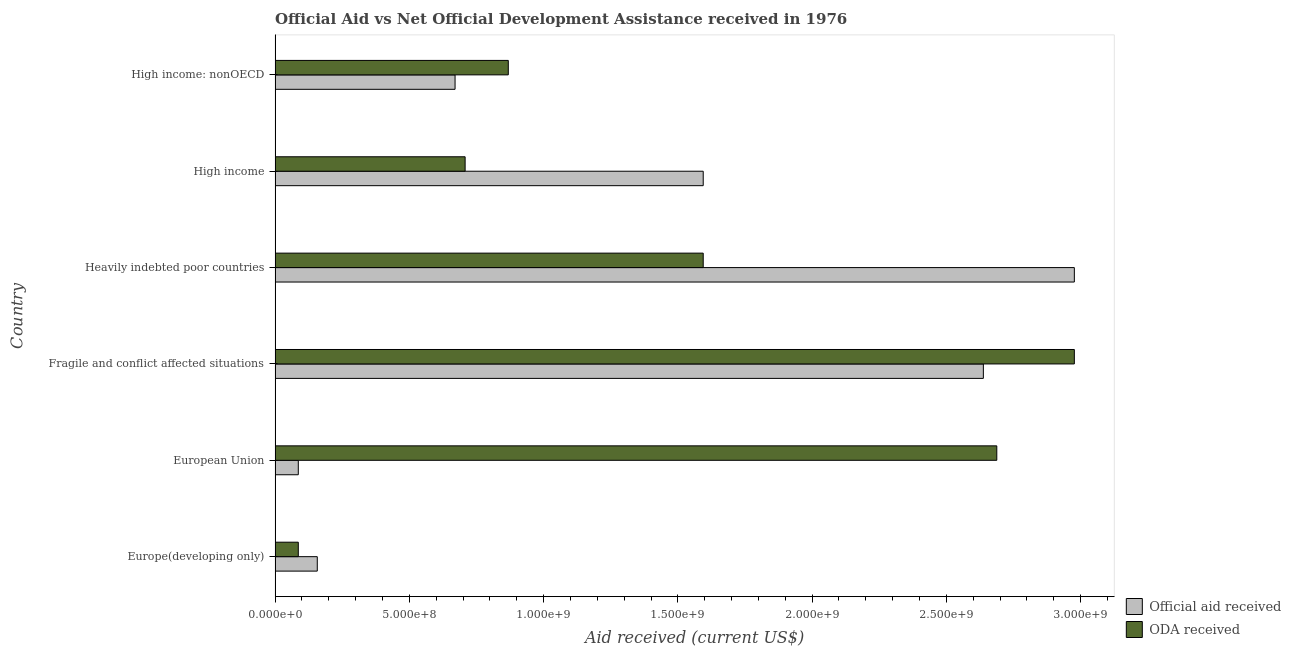How many different coloured bars are there?
Give a very brief answer. 2. Are the number of bars per tick equal to the number of legend labels?
Your answer should be compact. Yes. Are the number of bars on each tick of the Y-axis equal?
Give a very brief answer. Yes. How many bars are there on the 3rd tick from the bottom?
Provide a short and direct response. 2. What is the label of the 3rd group of bars from the top?
Your response must be concise. Heavily indebted poor countries. What is the official aid received in Europe(developing only)?
Offer a terse response. 1.57e+08. Across all countries, what is the maximum official aid received?
Provide a short and direct response. 2.98e+09. Across all countries, what is the minimum oda received?
Your answer should be compact. 8.65e+07. In which country was the official aid received maximum?
Provide a short and direct response. Heavily indebted poor countries. In which country was the oda received minimum?
Offer a terse response. Europe(developing only). What is the total oda received in the graph?
Your answer should be compact. 8.92e+09. What is the difference between the official aid received in Heavily indebted poor countries and that in High income: nonOECD?
Ensure brevity in your answer.  2.31e+09. What is the difference between the official aid received in High income and the oda received in High income: nonOECD?
Make the answer very short. 7.26e+08. What is the average oda received per country?
Your answer should be compact. 1.49e+09. What is the difference between the official aid received and oda received in Europe(developing only)?
Offer a very short reply. 7.07e+07. In how many countries, is the oda received greater than 2300000000 US$?
Give a very brief answer. 2. What is the ratio of the oda received in Europe(developing only) to that in Heavily indebted poor countries?
Ensure brevity in your answer.  0.05. Is the oda received in Europe(developing only) less than that in High income?
Provide a short and direct response. Yes. Is the difference between the oda received in Europe(developing only) and High income: nonOECD greater than the difference between the official aid received in Europe(developing only) and High income: nonOECD?
Ensure brevity in your answer.  No. What is the difference between the highest and the second highest official aid received?
Offer a very short reply. 3.39e+08. What is the difference between the highest and the lowest official aid received?
Provide a short and direct response. 2.89e+09. In how many countries, is the oda received greater than the average oda received taken over all countries?
Offer a very short reply. 3. Is the sum of the oda received in Fragile and conflict affected situations and Heavily indebted poor countries greater than the maximum official aid received across all countries?
Offer a very short reply. Yes. What does the 1st bar from the top in High income: nonOECD represents?
Offer a very short reply. ODA received. What does the 1st bar from the bottom in High income: nonOECD represents?
Provide a succinct answer. Official aid received. How many bars are there?
Make the answer very short. 12. How many countries are there in the graph?
Keep it short and to the point. 6. What is the difference between two consecutive major ticks on the X-axis?
Provide a succinct answer. 5.00e+08. Are the values on the major ticks of X-axis written in scientific E-notation?
Ensure brevity in your answer.  Yes. How are the legend labels stacked?
Offer a very short reply. Vertical. What is the title of the graph?
Your answer should be compact. Official Aid vs Net Official Development Assistance received in 1976 . What is the label or title of the X-axis?
Offer a very short reply. Aid received (current US$). What is the label or title of the Y-axis?
Ensure brevity in your answer.  Country. What is the Aid received (current US$) of Official aid received in Europe(developing only)?
Keep it short and to the point. 1.57e+08. What is the Aid received (current US$) in ODA received in Europe(developing only)?
Your answer should be very brief. 8.65e+07. What is the Aid received (current US$) of Official aid received in European Union?
Ensure brevity in your answer.  8.65e+07. What is the Aid received (current US$) in ODA received in European Union?
Your answer should be compact. 2.69e+09. What is the Aid received (current US$) of Official aid received in Fragile and conflict affected situations?
Keep it short and to the point. 2.64e+09. What is the Aid received (current US$) in ODA received in Fragile and conflict affected situations?
Your answer should be very brief. 2.98e+09. What is the Aid received (current US$) in Official aid received in Heavily indebted poor countries?
Give a very brief answer. 2.98e+09. What is the Aid received (current US$) in ODA received in Heavily indebted poor countries?
Offer a very short reply. 1.59e+09. What is the Aid received (current US$) of Official aid received in High income?
Your response must be concise. 1.59e+09. What is the Aid received (current US$) of ODA received in High income?
Your answer should be very brief. 7.08e+08. What is the Aid received (current US$) in Official aid received in High income: nonOECD?
Make the answer very short. 6.70e+08. What is the Aid received (current US$) of ODA received in High income: nonOECD?
Provide a short and direct response. 8.69e+08. Across all countries, what is the maximum Aid received (current US$) in Official aid received?
Your answer should be very brief. 2.98e+09. Across all countries, what is the maximum Aid received (current US$) of ODA received?
Your answer should be compact. 2.98e+09. Across all countries, what is the minimum Aid received (current US$) in Official aid received?
Keep it short and to the point. 8.65e+07. Across all countries, what is the minimum Aid received (current US$) of ODA received?
Give a very brief answer. 8.65e+07. What is the total Aid received (current US$) of Official aid received in the graph?
Offer a very short reply. 8.12e+09. What is the total Aid received (current US$) of ODA received in the graph?
Your answer should be very brief. 8.92e+09. What is the difference between the Aid received (current US$) of Official aid received in Europe(developing only) and that in European Union?
Make the answer very short. 7.07e+07. What is the difference between the Aid received (current US$) in ODA received in Europe(developing only) and that in European Union?
Offer a very short reply. -2.60e+09. What is the difference between the Aid received (current US$) of Official aid received in Europe(developing only) and that in Fragile and conflict affected situations?
Keep it short and to the point. -2.48e+09. What is the difference between the Aid received (current US$) in ODA received in Europe(developing only) and that in Fragile and conflict affected situations?
Your answer should be very brief. -2.89e+09. What is the difference between the Aid received (current US$) of Official aid received in Europe(developing only) and that in Heavily indebted poor countries?
Provide a short and direct response. -2.82e+09. What is the difference between the Aid received (current US$) in ODA received in Europe(developing only) and that in Heavily indebted poor countries?
Give a very brief answer. -1.51e+09. What is the difference between the Aid received (current US$) in Official aid received in Europe(developing only) and that in High income?
Offer a very short reply. -1.44e+09. What is the difference between the Aid received (current US$) of ODA received in Europe(developing only) and that in High income?
Give a very brief answer. -6.21e+08. What is the difference between the Aid received (current US$) in Official aid received in Europe(developing only) and that in High income: nonOECD?
Keep it short and to the point. -5.13e+08. What is the difference between the Aid received (current US$) in ODA received in Europe(developing only) and that in High income: nonOECD?
Ensure brevity in your answer.  -7.82e+08. What is the difference between the Aid received (current US$) of Official aid received in European Union and that in Fragile and conflict affected situations?
Offer a very short reply. -2.55e+09. What is the difference between the Aid received (current US$) in ODA received in European Union and that in Fragile and conflict affected situations?
Your response must be concise. -2.89e+08. What is the difference between the Aid received (current US$) in Official aid received in European Union and that in Heavily indebted poor countries?
Keep it short and to the point. -2.89e+09. What is the difference between the Aid received (current US$) in ODA received in European Union and that in Heavily indebted poor countries?
Provide a short and direct response. 1.09e+09. What is the difference between the Aid received (current US$) of Official aid received in European Union and that in High income?
Provide a short and direct response. -1.51e+09. What is the difference between the Aid received (current US$) of ODA received in European Union and that in High income?
Your answer should be very brief. 1.98e+09. What is the difference between the Aid received (current US$) of Official aid received in European Union and that in High income: nonOECD?
Your answer should be compact. -5.84e+08. What is the difference between the Aid received (current US$) in ODA received in European Union and that in High income: nonOECD?
Your answer should be compact. 1.82e+09. What is the difference between the Aid received (current US$) in Official aid received in Fragile and conflict affected situations and that in Heavily indebted poor countries?
Ensure brevity in your answer.  -3.39e+08. What is the difference between the Aid received (current US$) in ODA received in Fragile and conflict affected situations and that in Heavily indebted poor countries?
Your response must be concise. 1.38e+09. What is the difference between the Aid received (current US$) of Official aid received in Fragile and conflict affected situations and that in High income?
Give a very brief answer. 1.04e+09. What is the difference between the Aid received (current US$) of ODA received in Fragile and conflict affected situations and that in High income?
Your answer should be compact. 2.27e+09. What is the difference between the Aid received (current US$) of Official aid received in Fragile and conflict affected situations and that in High income: nonOECD?
Give a very brief answer. 1.97e+09. What is the difference between the Aid received (current US$) of ODA received in Fragile and conflict affected situations and that in High income: nonOECD?
Provide a succinct answer. 2.11e+09. What is the difference between the Aid received (current US$) in Official aid received in Heavily indebted poor countries and that in High income?
Offer a terse response. 1.38e+09. What is the difference between the Aid received (current US$) in ODA received in Heavily indebted poor countries and that in High income?
Offer a terse response. 8.87e+08. What is the difference between the Aid received (current US$) in Official aid received in Heavily indebted poor countries and that in High income: nonOECD?
Ensure brevity in your answer.  2.31e+09. What is the difference between the Aid received (current US$) in ODA received in Heavily indebted poor countries and that in High income: nonOECD?
Provide a short and direct response. 7.26e+08. What is the difference between the Aid received (current US$) of Official aid received in High income and that in High income: nonOECD?
Provide a short and direct response. 9.24e+08. What is the difference between the Aid received (current US$) in ODA received in High income and that in High income: nonOECD?
Offer a terse response. -1.61e+08. What is the difference between the Aid received (current US$) in Official aid received in Europe(developing only) and the Aid received (current US$) in ODA received in European Union?
Offer a very short reply. -2.53e+09. What is the difference between the Aid received (current US$) in Official aid received in Europe(developing only) and the Aid received (current US$) in ODA received in Fragile and conflict affected situations?
Keep it short and to the point. -2.82e+09. What is the difference between the Aid received (current US$) of Official aid received in Europe(developing only) and the Aid received (current US$) of ODA received in Heavily indebted poor countries?
Your answer should be very brief. -1.44e+09. What is the difference between the Aid received (current US$) of Official aid received in Europe(developing only) and the Aid received (current US$) of ODA received in High income?
Make the answer very short. -5.51e+08. What is the difference between the Aid received (current US$) in Official aid received in Europe(developing only) and the Aid received (current US$) in ODA received in High income: nonOECD?
Offer a very short reply. -7.11e+08. What is the difference between the Aid received (current US$) of Official aid received in European Union and the Aid received (current US$) of ODA received in Fragile and conflict affected situations?
Make the answer very short. -2.89e+09. What is the difference between the Aid received (current US$) of Official aid received in European Union and the Aid received (current US$) of ODA received in Heavily indebted poor countries?
Ensure brevity in your answer.  -1.51e+09. What is the difference between the Aid received (current US$) in Official aid received in European Union and the Aid received (current US$) in ODA received in High income?
Your answer should be compact. -6.21e+08. What is the difference between the Aid received (current US$) in Official aid received in European Union and the Aid received (current US$) in ODA received in High income: nonOECD?
Provide a succinct answer. -7.82e+08. What is the difference between the Aid received (current US$) of Official aid received in Fragile and conflict affected situations and the Aid received (current US$) of ODA received in Heavily indebted poor countries?
Give a very brief answer. 1.04e+09. What is the difference between the Aid received (current US$) in Official aid received in Fragile and conflict affected situations and the Aid received (current US$) in ODA received in High income?
Provide a succinct answer. 1.93e+09. What is the difference between the Aid received (current US$) of Official aid received in Fragile and conflict affected situations and the Aid received (current US$) of ODA received in High income: nonOECD?
Your answer should be very brief. 1.77e+09. What is the difference between the Aid received (current US$) of Official aid received in Heavily indebted poor countries and the Aid received (current US$) of ODA received in High income?
Your answer should be compact. 2.27e+09. What is the difference between the Aid received (current US$) in Official aid received in Heavily indebted poor countries and the Aid received (current US$) in ODA received in High income: nonOECD?
Give a very brief answer. 2.11e+09. What is the difference between the Aid received (current US$) in Official aid received in High income and the Aid received (current US$) in ODA received in High income: nonOECD?
Offer a terse response. 7.26e+08. What is the average Aid received (current US$) in Official aid received per country?
Offer a very short reply. 1.35e+09. What is the average Aid received (current US$) in ODA received per country?
Provide a short and direct response. 1.49e+09. What is the difference between the Aid received (current US$) of Official aid received and Aid received (current US$) of ODA received in Europe(developing only)?
Ensure brevity in your answer.  7.07e+07. What is the difference between the Aid received (current US$) of Official aid received and Aid received (current US$) of ODA received in European Union?
Your response must be concise. -2.60e+09. What is the difference between the Aid received (current US$) of Official aid received and Aid received (current US$) of ODA received in Fragile and conflict affected situations?
Offer a terse response. -3.39e+08. What is the difference between the Aid received (current US$) in Official aid received and Aid received (current US$) in ODA received in Heavily indebted poor countries?
Your answer should be very brief. 1.38e+09. What is the difference between the Aid received (current US$) of Official aid received and Aid received (current US$) of ODA received in High income?
Keep it short and to the point. 8.87e+08. What is the difference between the Aid received (current US$) of Official aid received and Aid received (current US$) of ODA received in High income: nonOECD?
Ensure brevity in your answer.  -1.98e+08. What is the ratio of the Aid received (current US$) of Official aid received in Europe(developing only) to that in European Union?
Provide a short and direct response. 1.82. What is the ratio of the Aid received (current US$) of ODA received in Europe(developing only) to that in European Union?
Your answer should be very brief. 0.03. What is the ratio of the Aid received (current US$) of Official aid received in Europe(developing only) to that in Fragile and conflict affected situations?
Ensure brevity in your answer.  0.06. What is the ratio of the Aid received (current US$) in ODA received in Europe(developing only) to that in Fragile and conflict affected situations?
Provide a succinct answer. 0.03. What is the ratio of the Aid received (current US$) in Official aid received in Europe(developing only) to that in Heavily indebted poor countries?
Provide a succinct answer. 0.05. What is the ratio of the Aid received (current US$) in ODA received in Europe(developing only) to that in Heavily indebted poor countries?
Offer a terse response. 0.05. What is the ratio of the Aid received (current US$) of Official aid received in Europe(developing only) to that in High income?
Provide a succinct answer. 0.1. What is the ratio of the Aid received (current US$) in ODA received in Europe(developing only) to that in High income?
Keep it short and to the point. 0.12. What is the ratio of the Aid received (current US$) in Official aid received in Europe(developing only) to that in High income: nonOECD?
Provide a short and direct response. 0.23. What is the ratio of the Aid received (current US$) in ODA received in Europe(developing only) to that in High income: nonOECD?
Offer a very short reply. 0.1. What is the ratio of the Aid received (current US$) in Official aid received in European Union to that in Fragile and conflict affected situations?
Your answer should be compact. 0.03. What is the ratio of the Aid received (current US$) of ODA received in European Union to that in Fragile and conflict affected situations?
Make the answer very short. 0.9. What is the ratio of the Aid received (current US$) in Official aid received in European Union to that in Heavily indebted poor countries?
Offer a very short reply. 0.03. What is the ratio of the Aid received (current US$) in ODA received in European Union to that in Heavily indebted poor countries?
Ensure brevity in your answer.  1.69. What is the ratio of the Aid received (current US$) of Official aid received in European Union to that in High income?
Offer a terse response. 0.05. What is the ratio of the Aid received (current US$) of ODA received in European Union to that in High income?
Make the answer very short. 3.8. What is the ratio of the Aid received (current US$) of Official aid received in European Union to that in High income: nonOECD?
Your answer should be compact. 0.13. What is the ratio of the Aid received (current US$) in ODA received in European Union to that in High income: nonOECD?
Your answer should be compact. 3.09. What is the ratio of the Aid received (current US$) in Official aid received in Fragile and conflict affected situations to that in Heavily indebted poor countries?
Your answer should be compact. 0.89. What is the ratio of the Aid received (current US$) in ODA received in Fragile and conflict affected situations to that in Heavily indebted poor countries?
Ensure brevity in your answer.  1.87. What is the ratio of the Aid received (current US$) in Official aid received in Fragile and conflict affected situations to that in High income?
Your response must be concise. 1.65. What is the ratio of the Aid received (current US$) in ODA received in Fragile and conflict affected situations to that in High income?
Make the answer very short. 4.21. What is the ratio of the Aid received (current US$) in Official aid received in Fragile and conflict affected situations to that in High income: nonOECD?
Your answer should be compact. 3.94. What is the ratio of the Aid received (current US$) of ODA received in Fragile and conflict affected situations to that in High income: nonOECD?
Your response must be concise. 3.43. What is the ratio of the Aid received (current US$) of Official aid received in Heavily indebted poor countries to that in High income?
Provide a short and direct response. 1.87. What is the ratio of the Aid received (current US$) of ODA received in Heavily indebted poor countries to that in High income?
Keep it short and to the point. 2.25. What is the ratio of the Aid received (current US$) of Official aid received in Heavily indebted poor countries to that in High income: nonOECD?
Provide a succinct answer. 4.44. What is the ratio of the Aid received (current US$) in ODA received in Heavily indebted poor countries to that in High income: nonOECD?
Provide a short and direct response. 1.84. What is the ratio of the Aid received (current US$) of Official aid received in High income to that in High income: nonOECD?
Make the answer very short. 2.38. What is the ratio of the Aid received (current US$) of ODA received in High income to that in High income: nonOECD?
Provide a short and direct response. 0.81. What is the difference between the highest and the second highest Aid received (current US$) in Official aid received?
Provide a short and direct response. 3.39e+08. What is the difference between the highest and the second highest Aid received (current US$) of ODA received?
Provide a short and direct response. 2.89e+08. What is the difference between the highest and the lowest Aid received (current US$) in Official aid received?
Your answer should be compact. 2.89e+09. What is the difference between the highest and the lowest Aid received (current US$) in ODA received?
Provide a short and direct response. 2.89e+09. 